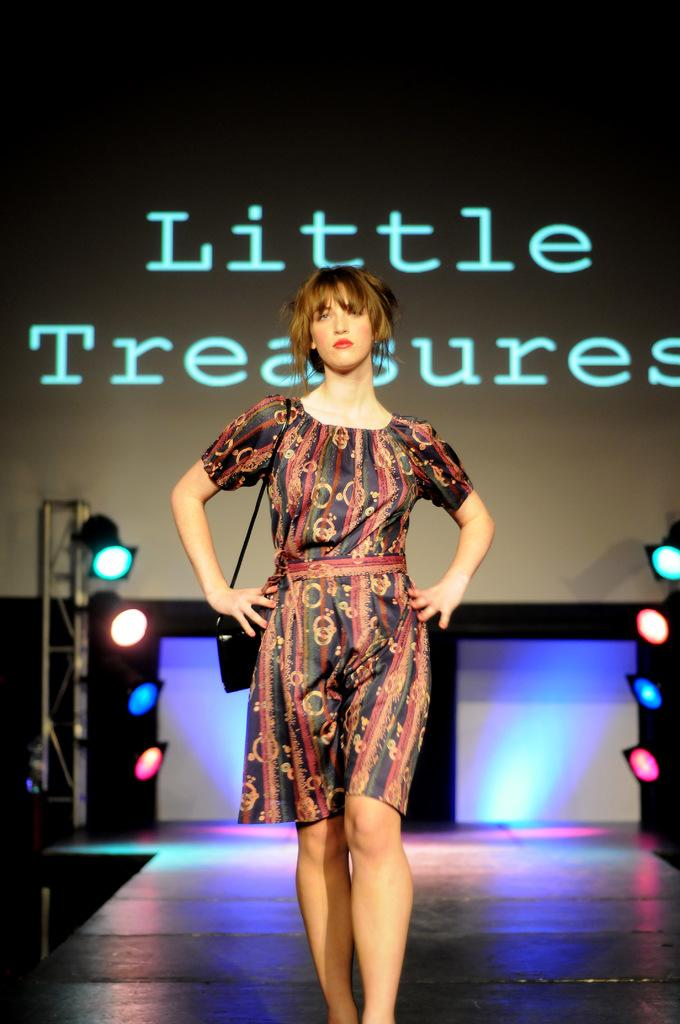What is the woman doing in the image? The woman is standing on the stage. What can be seen on both sides of the stage? There are lights on both sides of the stage. What is present in the background of the image? There is a presentation screen in the background. What type of kite is the woman flying on the stage? There is no kite present in the image; the woman is standing on the stage. How does the snail contribute to the presentation on the stage? There is no snail present in the image; the focus is on the woman standing on the stage and the presentation screen in the background. 